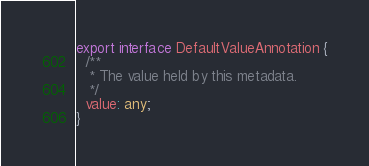Convert code to text. <code><loc_0><loc_0><loc_500><loc_500><_TypeScript_>export interface DefaultValueAnnotation {
  /**
   * The value held by this metadata.
   */
  value: any;
}
</code> 